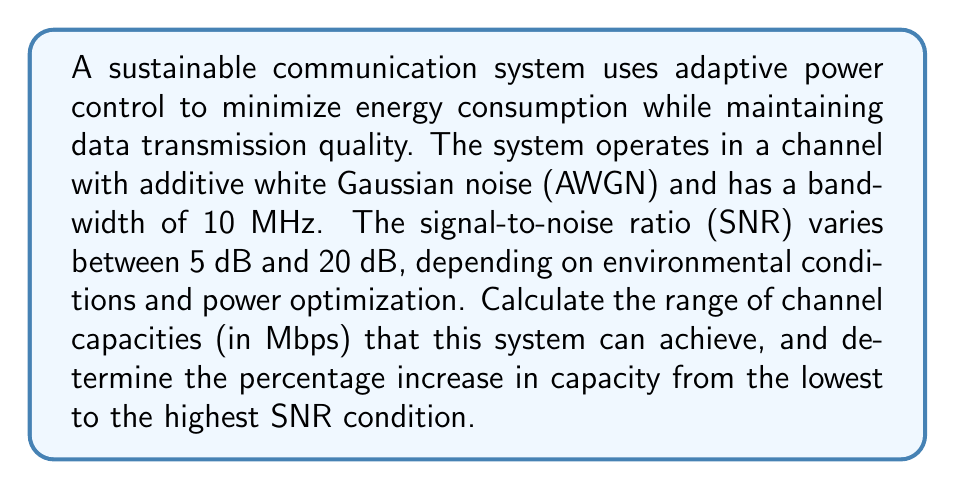Provide a solution to this math problem. To solve this problem, we'll use the Shannon-Hartley theorem, which gives the channel capacity for an AWGN channel. The theorem states:

$$ C = B \log_2(1 + SNR) $$

Where:
- $C$ is the channel capacity in bits per second
- $B$ is the bandwidth in Hz
- $SNR$ is the signal-to-noise ratio (linear, not dB)

Steps to solve:

1. Convert SNR from dB to linear scale:
   - For 5 dB: $SNR_{linear} = 10^{5/10} \approx 3.16$
   - For 20 dB: $SNR_{linear} = 10^{20/10} = 100$

2. Calculate channel capacity for lowest SNR (5 dB):
   $$ C_{min} = 10 \times 10^6 \log_2(1 + 3.16) $$
   $$ C_{min} = 10 \times 10^6 \times 2.00 = 20.00 \times 10^6 \text{ bps} = 20.00 \text{ Mbps} $$

3. Calculate channel capacity for highest SNR (20 dB):
   $$ C_{max} = 10 \times 10^6 \log_2(1 + 100) $$
   $$ C_{max} = 10 \times 10^6 \times 6.66 = 66.60 \times 10^6 \text{ bps} = 66.60 \text{ Mbps} $$

4. Calculate the percentage increase:
   $$ \text{Percentage increase} = \frac{C_{max} - C_{min}}{C_{min}} \times 100\% $$
   $$ = \frac{66.60 - 20.00}{20.00} \times 100\% = 233\% $$

This analysis shows how adaptive power control in a sustainable communication system can significantly affect channel capacity, allowing for energy-efficient operation in varying conditions while maintaining the ability to deliver higher data rates when needed.
Answer: The channel capacity ranges from 20.00 Mbps to 66.60 Mbps, with a 233% increase from the lowest to the highest SNR condition. 